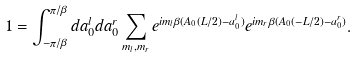Convert formula to latex. <formula><loc_0><loc_0><loc_500><loc_500>1 = \int _ { - \pi / \beta } ^ { \pi / \beta } d a ^ { l } _ { 0 } d a ^ { r } _ { 0 } \sum _ { m _ { l } , m _ { r } } e ^ { i m _ { l } \beta ( A _ { 0 } ( L / 2 ) - a ^ { l } _ { 0 } ) } e ^ { i m _ { r } \beta ( A _ { 0 } ( - L / 2 ) - a ^ { r } _ { 0 } ) } .</formula> 